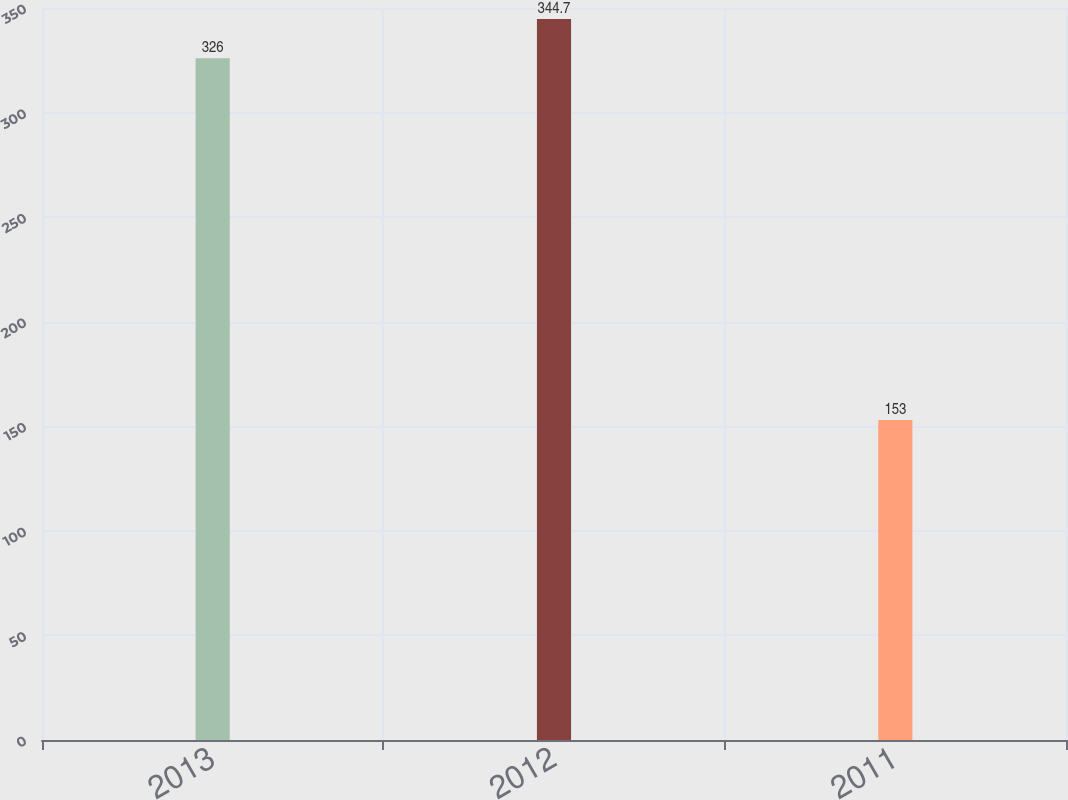Convert chart. <chart><loc_0><loc_0><loc_500><loc_500><bar_chart><fcel>2013<fcel>2012<fcel>2011<nl><fcel>326<fcel>344.7<fcel>153<nl></chart> 